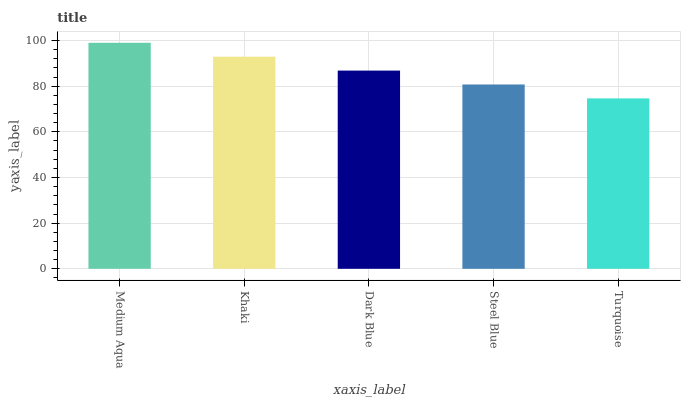Is Khaki the minimum?
Answer yes or no. No. Is Khaki the maximum?
Answer yes or no. No. Is Medium Aqua greater than Khaki?
Answer yes or no. Yes. Is Khaki less than Medium Aqua?
Answer yes or no. Yes. Is Khaki greater than Medium Aqua?
Answer yes or no. No. Is Medium Aqua less than Khaki?
Answer yes or no. No. Is Dark Blue the high median?
Answer yes or no. Yes. Is Dark Blue the low median?
Answer yes or no. Yes. Is Medium Aqua the high median?
Answer yes or no. No. Is Khaki the low median?
Answer yes or no. No. 